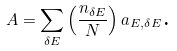Convert formula to latex. <formula><loc_0><loc_0><loc_500><loc_500>A = \sum _ { \delta E } \left ( \frac { n _ { \delta E } } { N } \right ) a _ { E , \delta E } \text {.}</formula> 